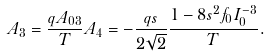<formula> <loc_0><loc_0><loc_500><loc_500>A _ { 3 } = \frac { q A _ { 0 3 } } { T } A _ { 4 } = - \frac { q s } { 2 \sqrt { 2 } } \frac { 1 - 8 s ^ { 2 } f _ { 0 } I _ { 0 } ^ { - 3 } } { T } .</formula> 